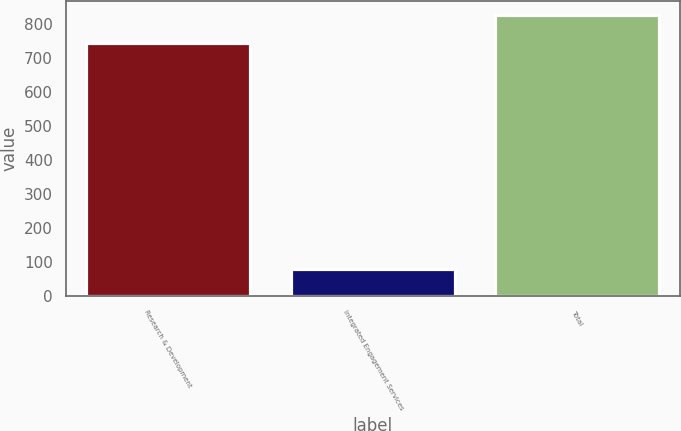Convert chart. <chart><loc_0><loc_0><loc_500><loc_500><bar_chart><fcel>Research & Development<fcel>Integrated Engagement Services<fcel>Total<nl><fcel>744<fcel>78<fcel>826<nl></chart> 